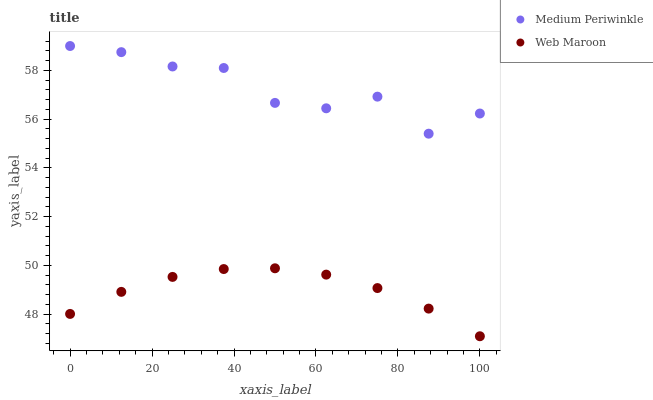Does Web Maroon have the minimum area under the curve?
Answer yes or no. Yes. Does Medium Periwinkle have the maximum area under the curve?
Answer yes or no. Yes. Does Medium Periwinkle have the minimum area under the curve?
Answer yes or no. No. Is Web Maroon the smoothest?
Answer yes or no. Yes. Is Medium Periwinkle the roughest?
Answer yes or no. Yes. Is Medium Periwinkle the smoothest?
Answer yes or no. No. Does Web Maroon have the lowest value?
Answer yes or no. Yes. Does Medium Periwinkle have the lowest value?
Answer yes or no. No. Does Medium Periwinkle have the highest value?
Answer yes or no. Yes. Is Web Maroon less than Medium Periwinkle?
Answer yes or no. Yes. Is Medium Periwinkle greater than Web Maroon?
Answer yes or no. Yes. Does Web Maroon intersect Medium Periwinkle?
Answer yes or no. No. 